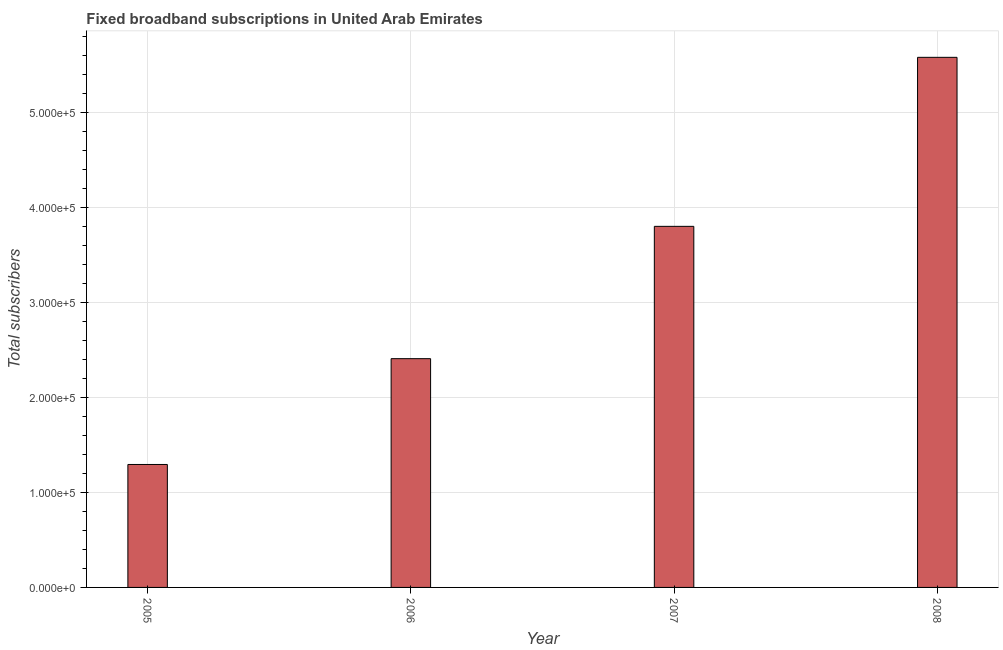Does the graph contain grids?
Provide a succinct answer. Yes. What is the title of the graph?
Ensure brevity in your answer.  Fixed broadband subscriptions in United Arab Emirates. What is the label or title of the Y-axis?
Make the answer very short. Total subscribers. What is the total number of fixed broadband subscriptions in 2006?
Provide a succinct answer. 2.41e+05. Across all years, what is the maximum total number of fixed broadband subscriptions?
Offer a very short reply. 5.58e+05. Across all years, what is the minimum total number of fixed broadband subscriptions?
Keep it short and to the point. 1.29e+05. In which year was the total number of fixed broadband subscriptions maximum?
Make the answer very short. 2008. In which year was the total number of fixed broadband subscriptions minimum?
Keep it short and to the point. 2005. What is the sum of the total number of fixed broadband subscriptions?
Provide a short and direct response. 1.31e+06. What is the difference between the total number of fixed broadband subscriptions in 2005 and 2008?
Make the answer very short. -4.28e+05. What is the average total number of fixed broadband subscriptions per year?
Keep it short and to the point. 3.27e+05. What is the median total number of fixed broadband subscriptions?
Provide a short and direct response. 3.10e+05. In how many years, is the total number of fixed broadband subscriptions greater than 440000 ?
Offer a very short reply. 1. Do a majority of the years between 2008 and 2006 (inclusive) have total number of fixed broadband subscriptions greater than 340000 ?
Your answer should be very brief. Yes. What is the ratio of the total number of fixed broadband subscriptions in 2007 to that in 2008?
Your response must be concise. 0.68. Is the total number of fixed broadband subscriptions in 2005 less than that in 2006?
Offer a terse response. Yes. Is the difference between the total number of fixed broadband subscriptions in 2005 and 2006 greater than the difference between any two years?
Offer a terse response. No. What is the difference between the highest and the second highest total number of fixed broadband subscriptions?
Offer a very short reply. 1.78e+05. What is the difference between the highest and the lowest total number of fixed broadband subscriptions?
Keep it short and to the point. 4.28e+05. In how many years, is the total number of fixed broadband subscriptions greater than the average total number of fixed broadband subscriptions taken over all years?
Make the answer very short. 2. How many years are there in the graph?
Make the answer very short. 4. Are the values on the major ticks of Y-axis written in scientific E-notation?
Offer a terse response. Yes. What is the Total subscribers in 2005?
Give a very brief answer. 1.29e+05. What is the Total subscribers of 2006?
Keep it short and to the point. 2.41e+05. What is the Total subscribers of 2007?
Give a very brief answer. 3.80e+05. What is the Total subscribers in 2008?
Offer a very short reply. 5.58e+05. What is the difference between the Total subscribers in 2005 and 2006?
Give a very brief answer. -1.11e+05. What is the difference between the Total subscribers in 2005 and 2007?
Offer a very short reply. -2.50e+05. What is the difference between the Total subscribers in 2005 and 2008?
Offer a terse response. -4.28e+05. What is the difference between the Total subscribers in 2006 and 2007?
Provide a succinct answer. -1.39e+05. What is the difference between the Total subscribers in 2006 and 2008?
Provide a short and direct response. -3.17e+05. What is the difference between the Total subscribers in 2007 and 2008?
Offer a terse response. -1.78e+05. What is the ratio of the Total subscribers in 2005 to that in 2006?
Your answer should be compact. 0.54. What is the ratio of the Total subscribers in 2005 to that in 2007?
Offer a very short reply. 0.34. What is the ratio of the Total subscribers in 2005 to that in 2008?
Your response must be concise. 0.23. What is the ratio of the Total subscribers in 2006 to that in 2007?
Provide a short and direct response. 0.63. What is the ratio of the Total subscribers in 2006 to that in 2008?
Your answer should be compact. 0.43. What is the ratio of the Total subscribers in 2007 to that in 2008?
Keep it short and to the point. 0.68. 